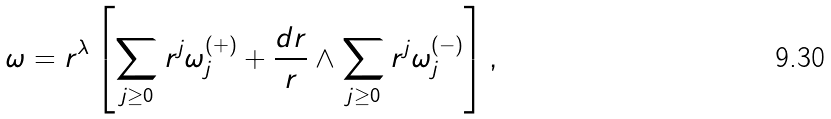Convert formula to latex. <formula><loc_0><loc_0><loc_500><loc_500>\omega = r ^ { \lambda } \left [ \sum _ { j \geq 0 } r ^ { j } \omega _ { j } ^ { ( + ) } + \frac { d r } { r } \wedge \sum _ { j \geq 0 } r ^ { j } \omega _ { j } ^ { ( - ) } \right ] ,</formula> 